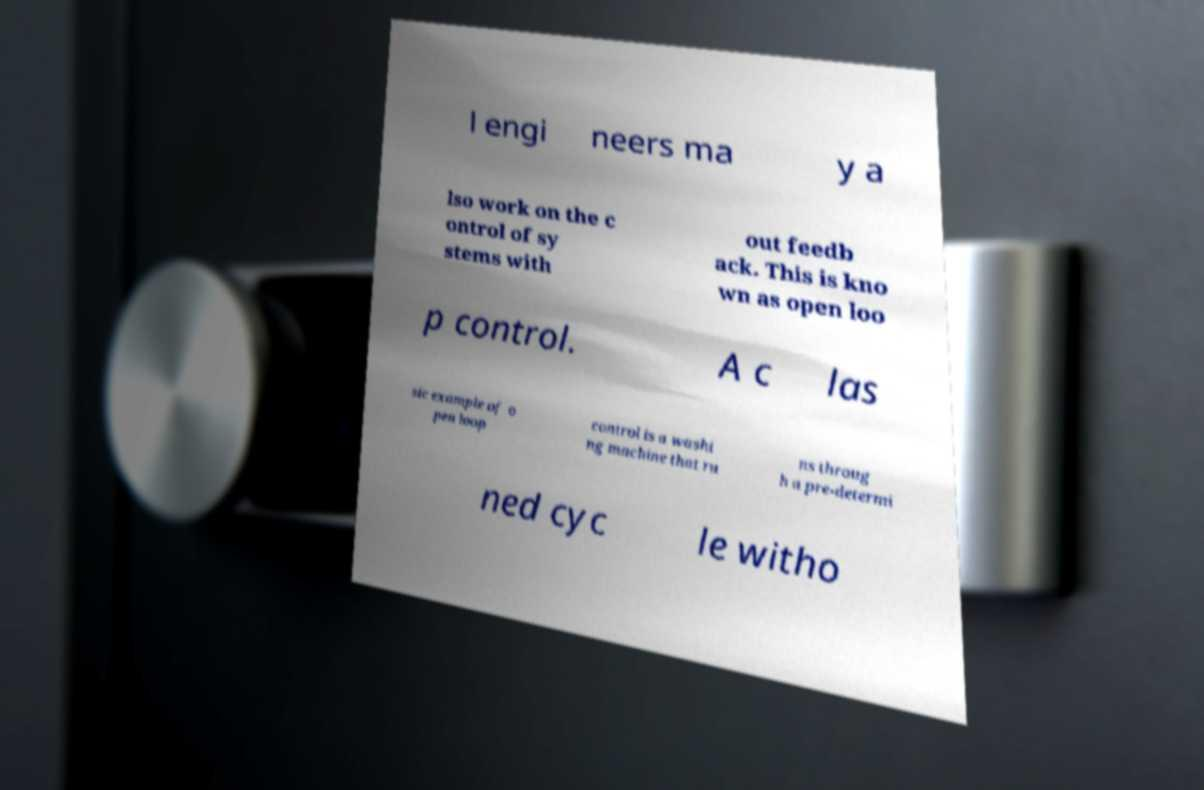Could you extract and type out the text from this image? l engi neers ma y a lso work on the c ontrol of sy stems with out feedb ack. This is kno wn as open loo p control. A c las sic example of o pen loop control is a washi ng machine that ru ns throug h a pre-determi ned cyc le witho 